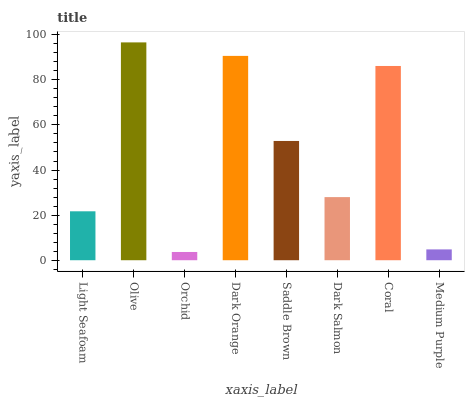Is Orchid the minimum?
Answer yes or no. Yes. Is Olive the maximum?
Answer yes or no. Yes. Is Olive the minimum?
Answer yes or no. No. Is Orchid the maximum?
Answer yes or no. No. Is Olive greater than Orchid?
Answer yes or no. Yes. Is Orchid less than Olive?
Answer yes or no. Yes. Is Orchid greater than Olive?
Answer yes or no. No. Is Olive less than Orchid?
Answer yes or no. No. Is Saddle Brown the high median?
Answer yes or no. Yes. Is Dark Salmon the low median?
Answer yes or no. Yes. Is Orchid the high median?
Answer yes or no. No. Is Dark Orange the low median?
Answer yes or no. No. 